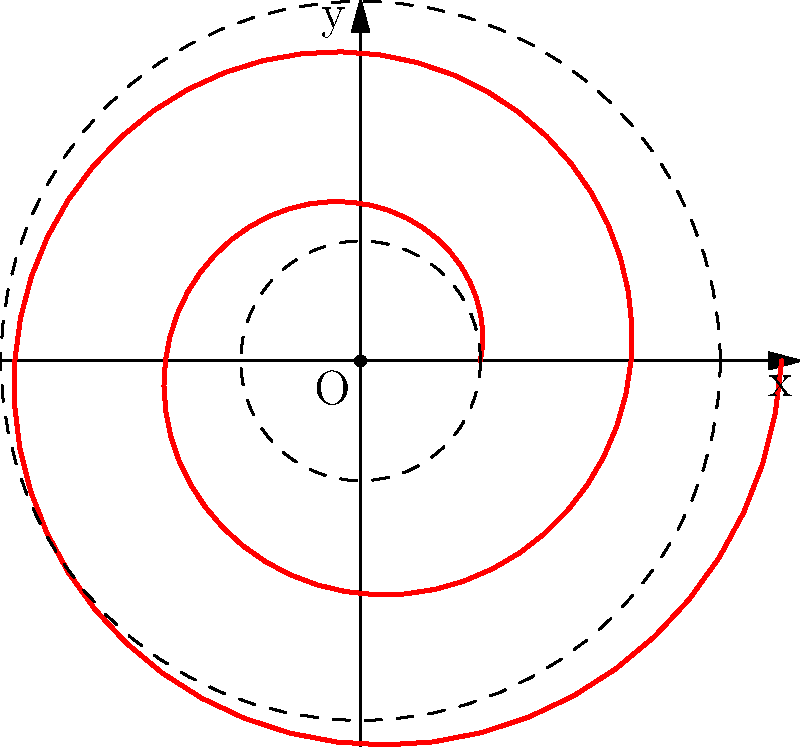A computer's cooling fan follows a spiral path represented by the polar equation $r = 0.5 + 0.1\theta$, where $r$ is in centimeters and $\theta$ is in radians. If the fan completes two full rotations, what is the total distance traveled by a point on the fan's blade? To solve this problem, we need to follow these steps:

1) The spiral makes two full rotations, so $\theta$ goes from 0 to $4\pi$ radians.

2) To find the length of a polar curve, we use the formula:

   $L = \int_a^b \sqrt{r^2 + (\frac{dr}{d\theta})^2} d\theta$

3) In our case, $r = 0.5 + 0.1\theta$ and $\frac{dr}{d\theta} = 0.1$

4) Substituting into the formula:

   $L = \int_0^{4\pi} \sqrt{(0.5 + 0.1\theta)^2 + 0.1^2} d\theta$

5) This integral is complex to solve analytically, so we would typically use numerical integration methods, which you might encounter in your computer science studies.

6) Using a numerical integration method (like Simpson's rule or Gaussian quadrature), we find that the length is approximately 10.21 cm.

This problem combines elements of computer hardware (cooling fan) with mathematical concepts (polar coordinates, calculus) that are relevant to your computer science studies, while the spiral path might remind you of the curved paths you had to consider in rugby.
Answer: $10.21$ cm 